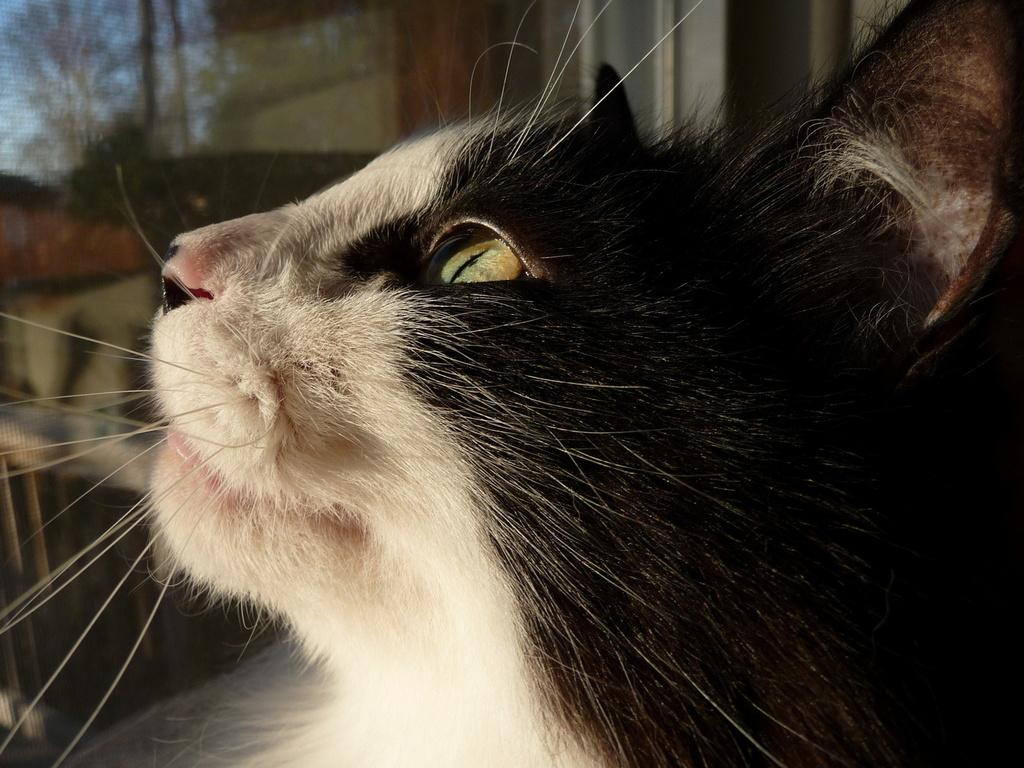What type of animal is present in the image? There is a cat in the image. What can be seen in the background of the image? There are trees and the sky visible in the background of the image. What emotion is the cat expressing towards the trees in the image? The cat's emotions cannot be determined from the image, as it does not display any clear expressions of attraction, anger, or care towards the trees. 